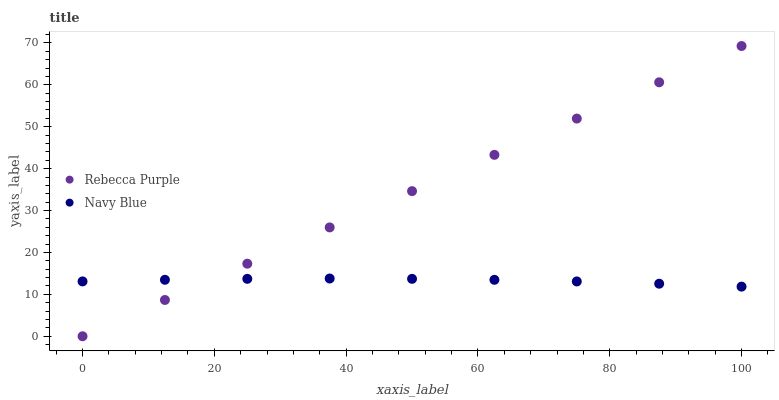Does Navy Blue have the minimum area under the curve?
Answer yes or no. Yes. Does Rebecca Purple have the maximum area under the curve?
Answer yes or no. Yes. Does Rebecca Purple have the minimum area under the curve?
Answer yes or no. No. Is Rebecca Purple the smoothest?
Answer yes or no. Yes. Is Navy Blue the roughest?
Answer yes or no. Yes. Is Rebecca Purple the roughest?
Answer yes or no. No. Does Rebecca Purple have the lowest value?
Answer yes or no. Yes. Does Rebecca Purple have the highest value?
Answer yes or no. Yes. Does Rebecca Purple intersect Navy Blue?
Answer yes or no. Yes. Is Rebecca Purple less than Navy Blue?
Answer yes or no. No. Is Rebecca Purple greater than Navy Blue?
Answer yes or no. No. 